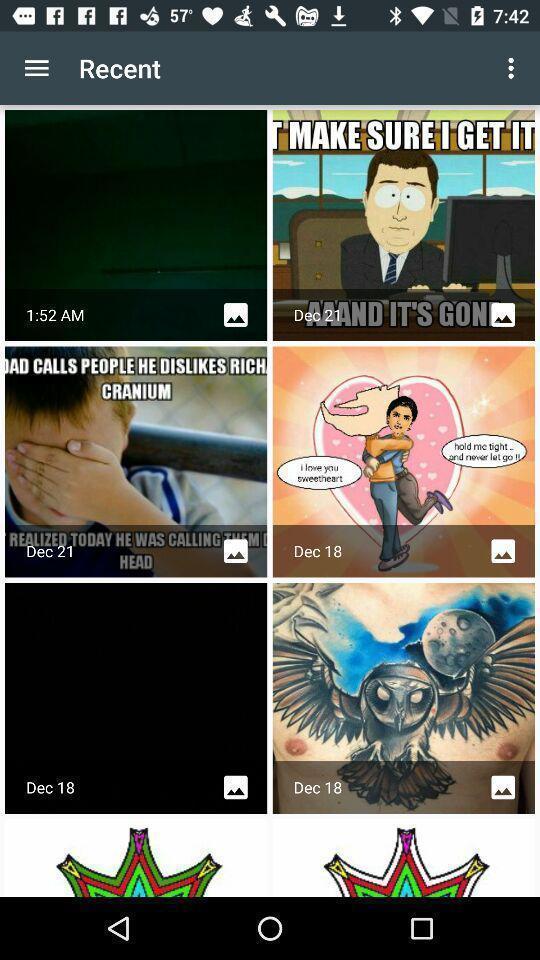Provide a detailed account of this screenshot. Page showing the multiple images. 